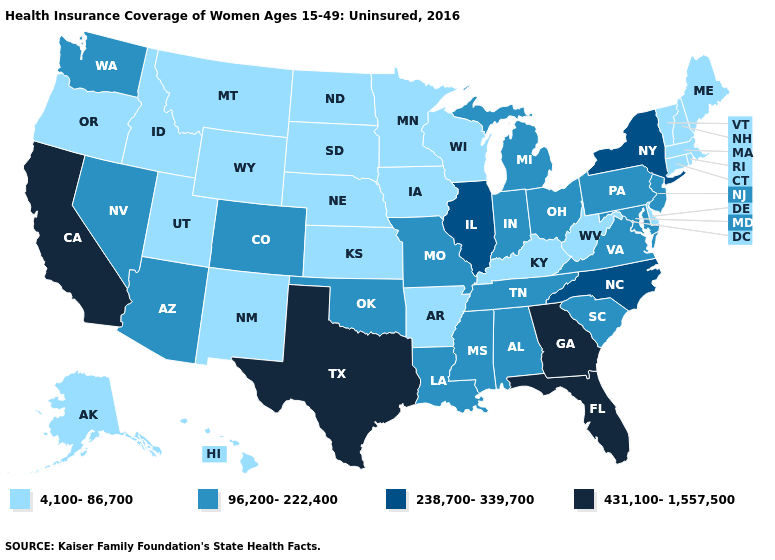What is the value of North Dakota?
Be succinct. 4,100-86,700. What is the value of North Dakota?
Concise answer only. 4,100-86,700. What is the value of South Carolina?
Concise answer only. 96,200-222,400. Among the states that border Utah , which have the lowest value?
Give a very brief answer. Idaho, New Mexico, Wyoming. What is the value of Vermont?
Be succinct. 4,100-86,700. Does the map have missing data?
Quick response, please. No. How many symbols are there in the legend?
Be succinct. 4. What is the value of Florida?
Give a very brief answer. 431,100-1,557,500. Which states have the lowest value in the USA?
Be succinct. Alaska, Arkansas, Connecticut, Delaware, Hawaii, Idaho, Iowa, Kansas, Kentucky, Maine, Massachusetts, Minnesota, Montana, Nebraska, New Hampshire, New Mexico, North Dakota, Oregon, Rhode Island, South Dakota, Utah, Vermont, West Virginia, Wisconsin, Wyoming. Name the states that have a value in the range 238,700-339,700?
Answer briefly. Illinois, New York, North Carolina. Does New Jersey have the same value as Michigan?
Be succinct. Yes. Name the states that have a value in the range 96,200-222,400?
Quick response, please. Alabama, Arizona, Colorado, Indiana, Louisiana, Maryland, Michigan, Mississippi, Missouri, Nevada, New Jersey, Ohio, Oklahoma, Pennsylvania, South Carolina, Tennessee, Virginia, Washington. Does the first symbol in the legend represent the smallest category?
Answer briefly. Yes. What is the value of Massachusetts?
Give a very brief answer. 4,100-86,700. Name the states that have a value in the range 238,700-339,700?
Short answer required. Illinois, New York, North Carolina. 